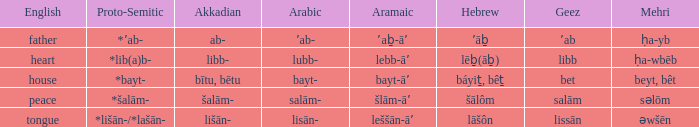When salām- is used in arabic, what is the related word in proto-semitic? *šalām-. 